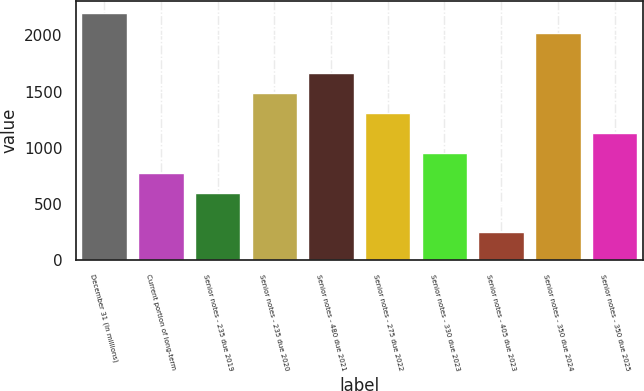Convert chart. <chart><loc_0><loc_0><loc_500><loc_500><bar_chart><fcel>December 31 (In millions)<fcel>Current portion of long-term<fcel>Senior notes - 235 due 2019<fcel>Senior notes - 235 due 2020<fcel>Senior notes - 480 due 2021<fcel>Senior notes - 275 due 2022<fcel>Senior notes - 330 due 2023<fcel>Senior notes - 405 due 2023<fcel>Senior notes - 350 due 2024<fcel>Senior notes - 350 due 2025<nl><fcel>2194.9<fcel>779.7<fcel>602.8<fcel>1487.3<fcel>1664.2<fcel>1310.4<fcel>956.6<fcel>249<fcel>2018<fcel>1133.5<nl></chart> 